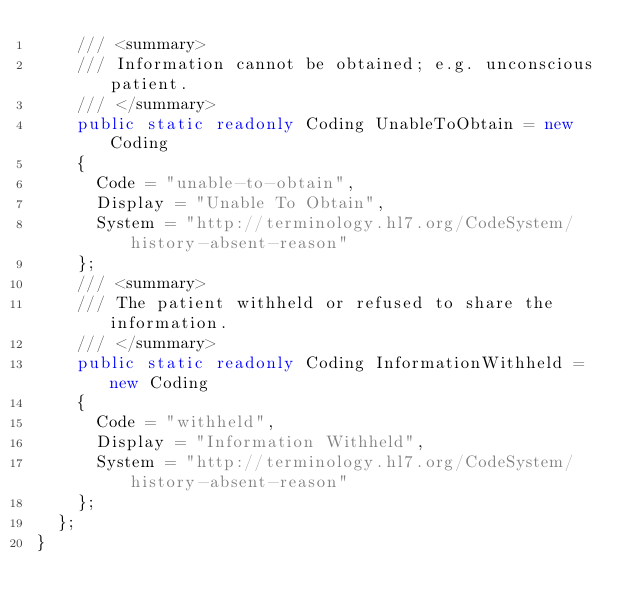Convert code to text. <code><loc_0><loc_0><loc_500><loc_500><_C#_>    /// <summary>
    /// Information cannot be obtained; e.g. unconscious patient.
    /// </summary>
    public static readonly Coding UnableToObtain = new Coding
    {
      Code = "unable-to-obtain",
      Display = "Unable To Obtain",
      System = "http://terminology.hl7.org/CodeSystem/history-absent-reason"
    };
    /// <summary>
    /// The patient withheld or refused to share the information.
    /// </summary>
    public static readonly Coding InformationWithheld = new Coding
    {
      Code = "withheld",
      Display = "Information Withheld",
      System = "http://terminology.hl7.org/CodeSystem/history-absent-reason"
    };
  };
}
</code> 